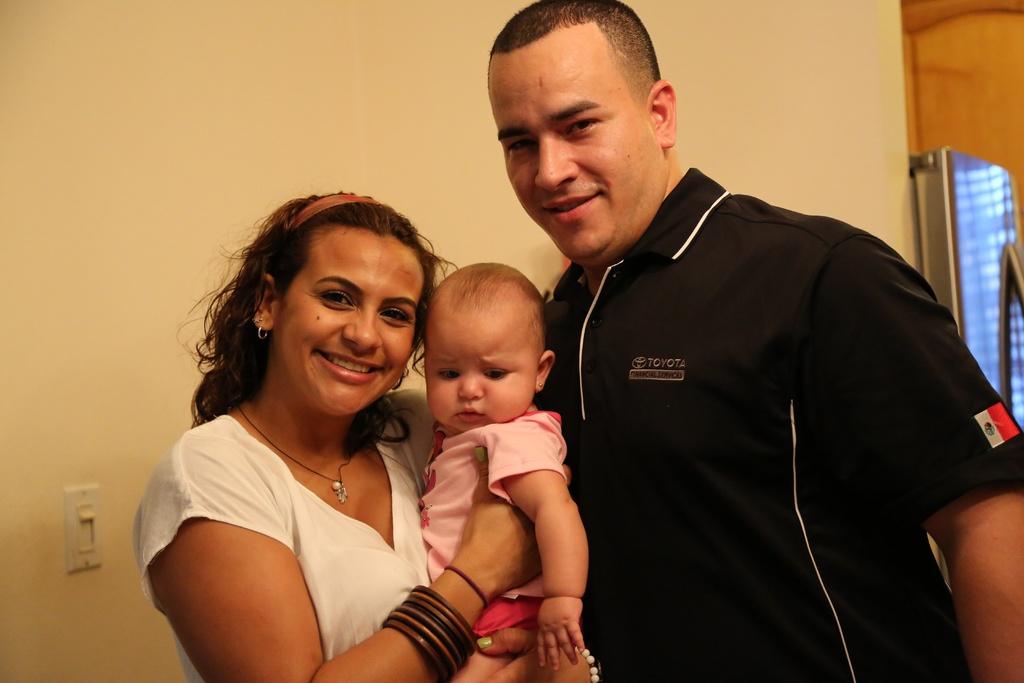How many persons in the image ?
Provide a short and direct response. Answering does not require reading text in the image. 